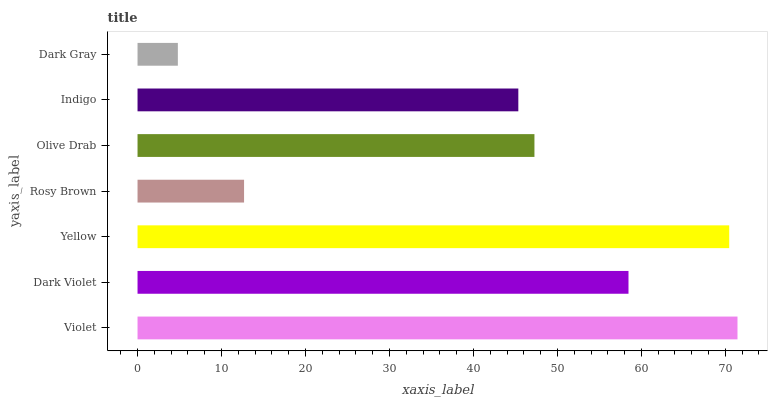Is Dark Gray the minimum?
Answer yes or no. Yes. Is Violet the maximum?
Answer yes or no. Yes. Is Dark Violet the minimum?
Answer yes or no. No. Is Dark Violet the maximum?
Answer yes or no. No. Is Violet greater than Dark Violet?
Answer yes or no. Yes. Is Dark Violet less than Violet?
Answer yes or no. Yes. Is Dark Violet greater than Violet?
Answer yes or no. No. Is Violet less than Dark Violet?
Answer yes or no. No. Is Olive Drab the high median?
Answer yes or no. Yes. Is Olive Drab the low median?
Answer yes or no. Yes. Is Yellow the high median?
Answer yes or no. No. Is Dark Gray the low median?
Answer yes or no. No. 